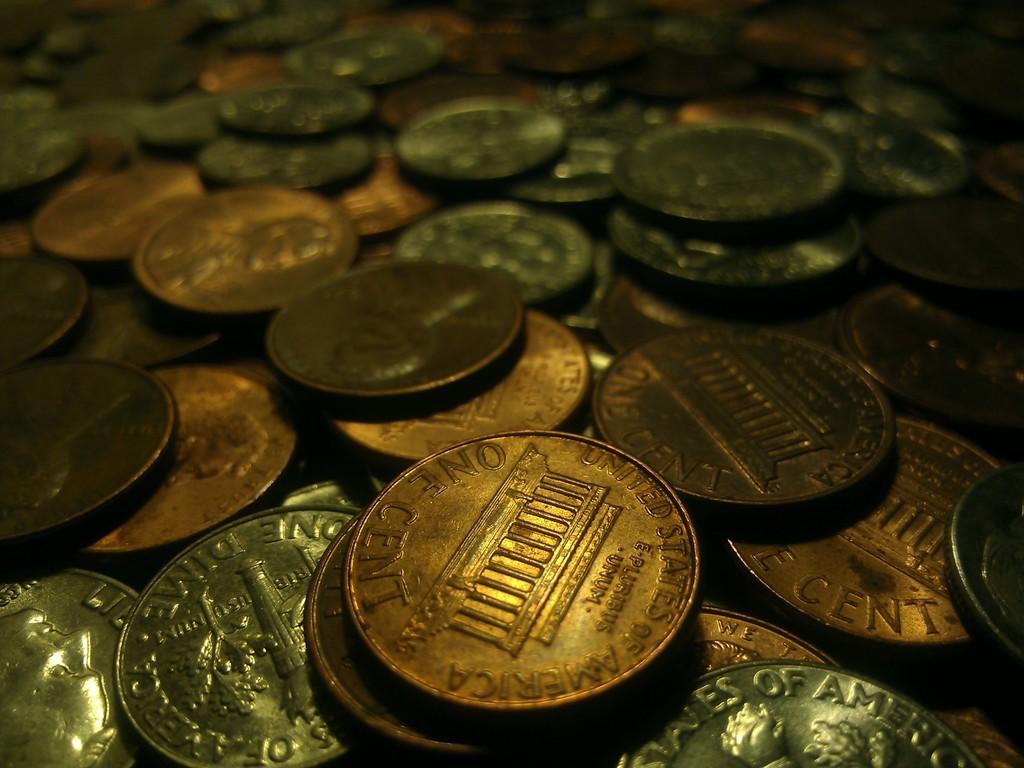How many cents is the copper colored coin worth?
Your answer should be compact. One. What country is mentioned on the coins?
Give a very brief answer. United states of america. 